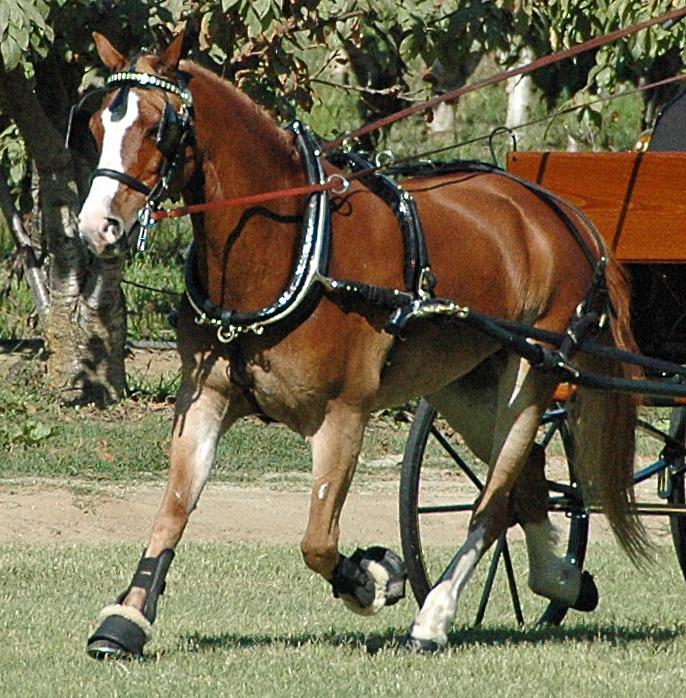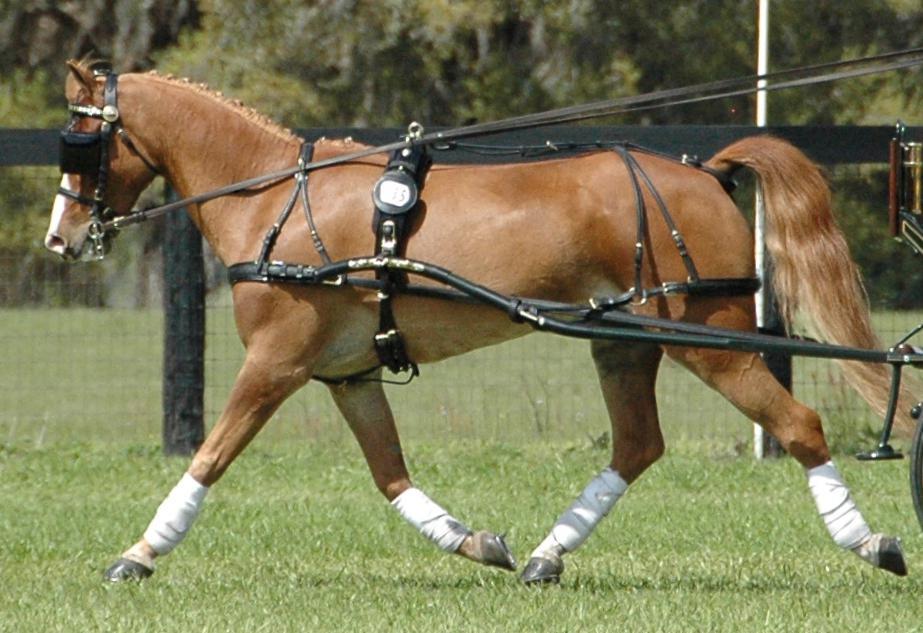The first image is the image on the left, the second image is the image on the right. For the images displayed, is the sentence "A man in a helmet is being pulled by at least one horse." factually correct? Answer yes or no. No. The first image is the image on the left, the second image is the image on the right. For the images shown, is this caption "There are exactly three horses." true? Answer yes or no. No. 